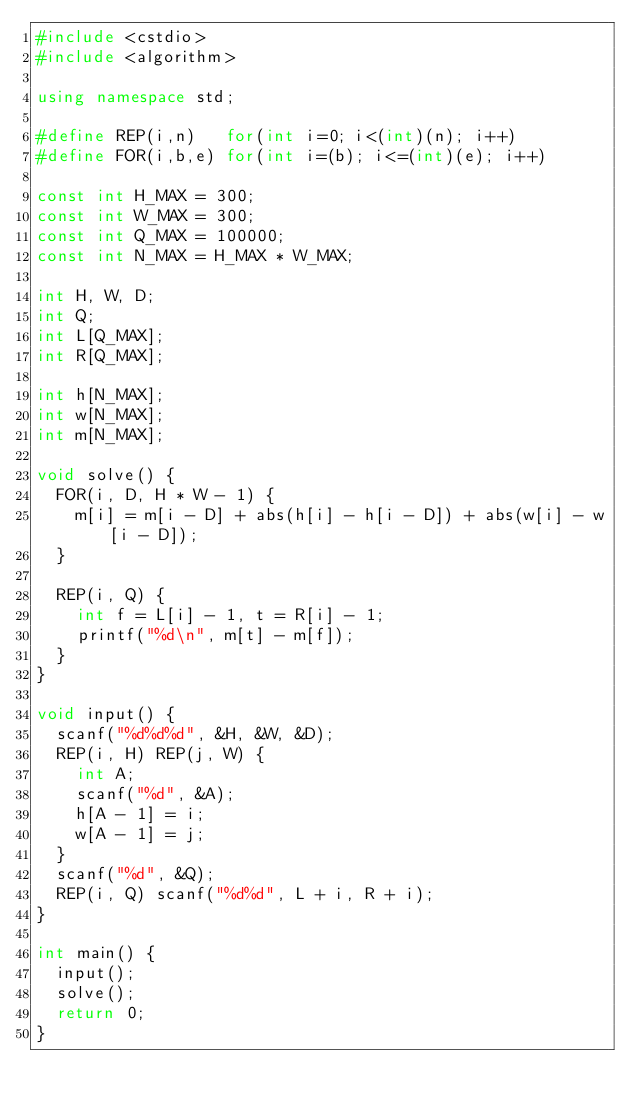Convert code to text. <code><loc_0><loc_0><loc_500><loc_500><_C++_>#include <cstdio>
#include <algorithm>

using namespace std;

#define REP(i,n)   for(int i=0; i<(int)(n); i++)
#define FOR(i,b,e) for(int i=(b); i<=(int)(e); i++)

const int H_MAX = 300;
const int W_MAX = 300;
const int Q_MAX = 100000;
const int N_MAX = H_MAX * W_MAX;

int H, W, D;
int Q;
int L[Q_MAX];
int R[Q_MAX];

int h[N_MAX];
int w[N_MAX];
int m[N_MAX];

void solve() {
  FOR(i, D, H * W - 1) {
    m[i] = m[i - D] + abs(h[i] - h[i - D]) + abs(w[i] - w[i - D]);
  }

  REP(i, Q) {
    int f = L[i] - 1, t = R[i] - 1;
    printf("%d\n", m[t] - m[f]);
  }
}

void input() {
  scanf("%d%d%d", &H, &W, &D);
  REP(i, H) REP(j, W) {
    int A;
    scanf("%d", &A);
    h[A - 1] = i;
    w[A - 1] = j;
  }
  scanf("%d", &Q);
  REP(i, Q) scanf("%d%d", L + i, R + i);
}

int main() {
  input();
  solve();
  return 0;
}
</code> 